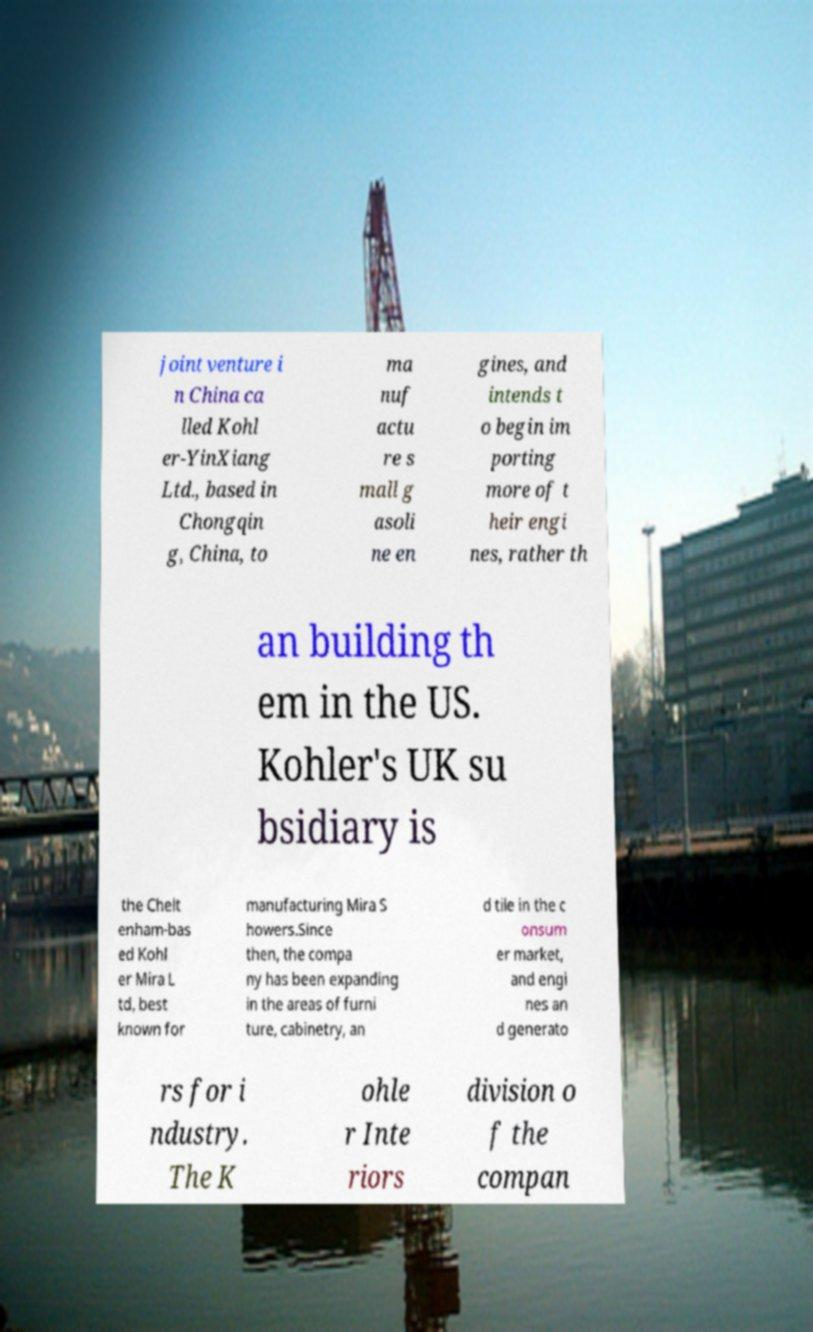I need the written content from this picture converted into text. Can you do that? joint venture i n China ca lled Kohl er-YinXiang Ltd., based in Chongqin g, China, to ma nuf actu re s mall g asoli ne en gines, and intends t o begin im porting more of t heir engi nes, rather th an building th em in the US. Kohler's UK su bsidiary is the Chelt enham-bas ed Kohl er Mira L td, best known for manufacturing Mira S howers.Since then, the compa ny has been expanding in the areas of furni ture, cabinetry, an d tile in the c onsum er market, and engi nes an d generato rs for i ndustry. The K ohle r Inte riors division o f the compan 